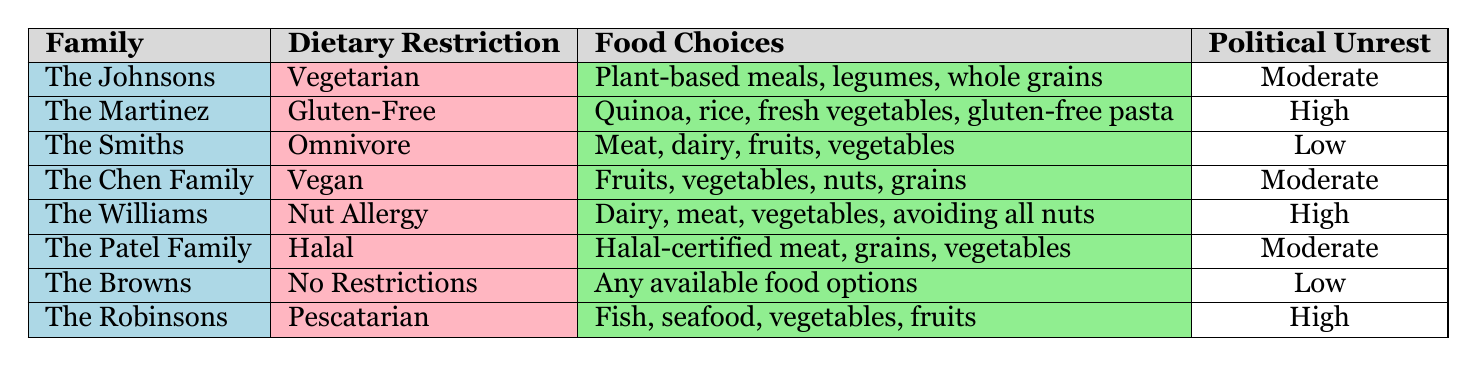What dietary restriction is associated with the highest period of political unrest? By reviewing the Political Unrest Period column for each family, both The Martinez (Gluten-Free) and The Robinsons (Pescatarian) are associated with a High period of political unrest.
Answer: Gluten-Free and Pescatarian How many families have a dietary restriction during the Moderate period of political unrest? In the table, we identify three families that have a Moderate period of political unrest: The Johnsons (Vegetarian), The Chen Family (Vegan), and The Patel Family (Halal). Therefore, that makes three families.
Answer: 3 Is there any family with no dietary restrictions during High political unrest? Referencing the table, we see that the families during High unrest are The Martinez, The Williams, and The Robinsons, none of whom have a dietary restriction listed as "No Restrictions." Thus, the answer is no.
Answer: No What is the average number of food choices listed for families during the Low political unrest? The families listed during Low unrest are The Smiths (4 choices), and The Browns (3 choices). To find the average: (4 + 3) / 2 = 3.5.
Answer: 3.5 Which family's food choices contain fruits? From the table, we find that The Chen Family (Vegan), The Robinsons (Pescatarian), and The Smiths (Omnivore) have food choices that include fruits.
Answer: The Chen Family, The Robinsons, The Smiths Are there any families with a Nut Allergy during a Low political unrest period? By examining the table, we see that the only family with a Nut Allergy is The Williams, which is listed during a High period of political unrest. Thus, the answer is no.
Answer: No 